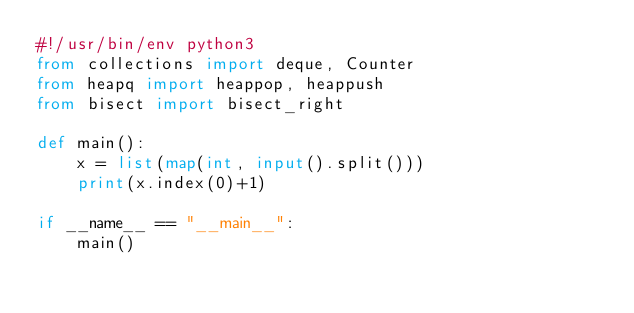<code> <loc_0><loc_0><loc_500><loc_500><_Python_>#!/usr/bin/env python3
from collections import deque, Counter
from heapq import heappop, heappush
from bisect import bisect_right

def main():
    x = list(map(int, input().split()))
    print(x.index(0)+1)

if __name__ == "__main__":
    main()
</code> 